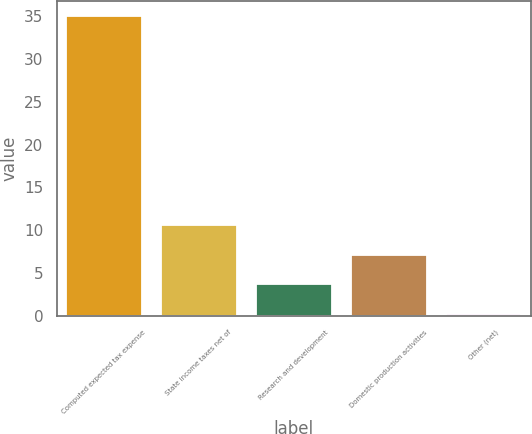Convert chart to OTSL. <chart><loc_0><loc_0><loc_500><loc_500><bar_chart><fcel>Computed expected tax expense<fcel>State income taxes net of<fcel>Research and development<fcel>Domestic production activities<fcel>Other (net)<nl><fcel>35<fcel>10.64<fcel>3.68<fcel>7.16<fcel>0.2<nl></chart> 